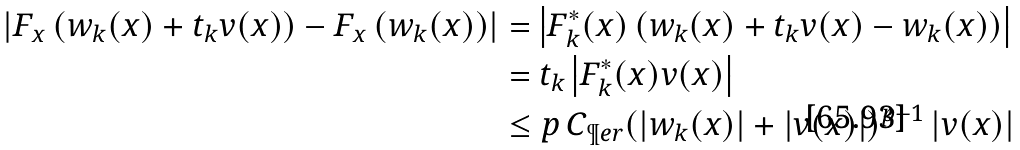<formula> <loc_0><loc_0><loc_500><loc_500>\left | F _ { x } \left ( w _ { k } ( x ) + t _ { k } v ( x ) \right ) - F _ { x } \left ( w _ { k } ( x ) \right ) \right | & = \left | F _ { k } ^ { * } ( x ) \left ( w _ { k } ( x ) + t _ { k } v ( x ) - w _ { k } ( x ) \right ) \right | \\ & = t _ { k } \left | F _ { k } ^ { * } ( x ) v ( x ) \right | \\ & \leq p \, C _ { \P e r } ( | w _ { k } ( x ) | + | v ( x ) | ) ^ { p - 1 } \, | v ( x ) | \,</formula> 